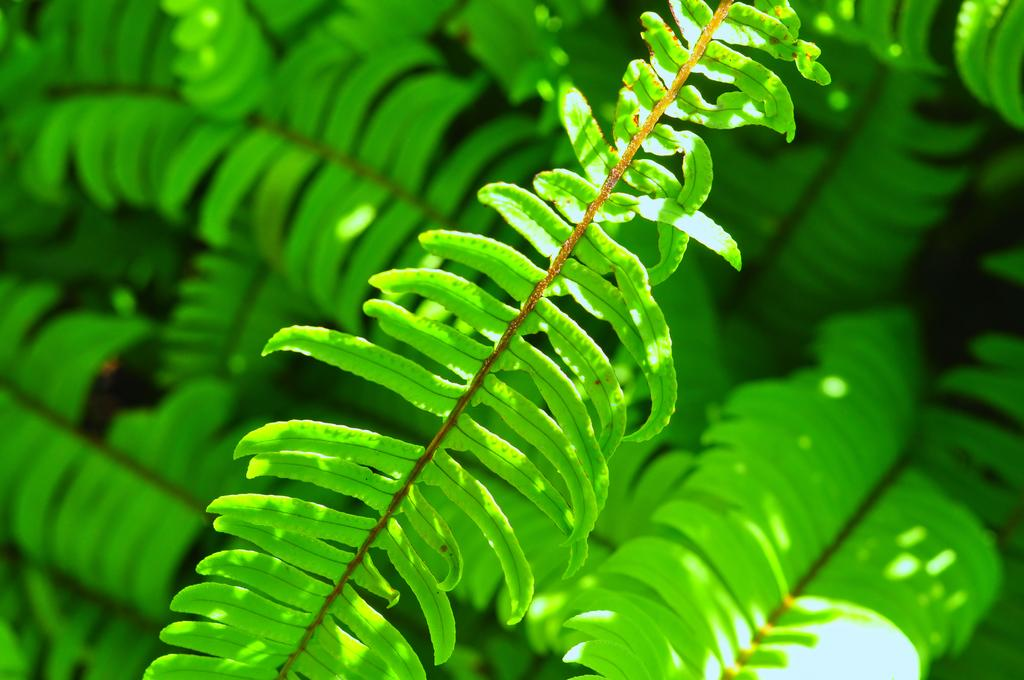What type of vegetation can be seen in the image? There are leaves in the image. What store is celebrating a birthday in the image? There is no store or birthday celebration present in the image; it only features leaves. How fast are the leaves running in the image? The leaves are not running in the image; they are stationary. 